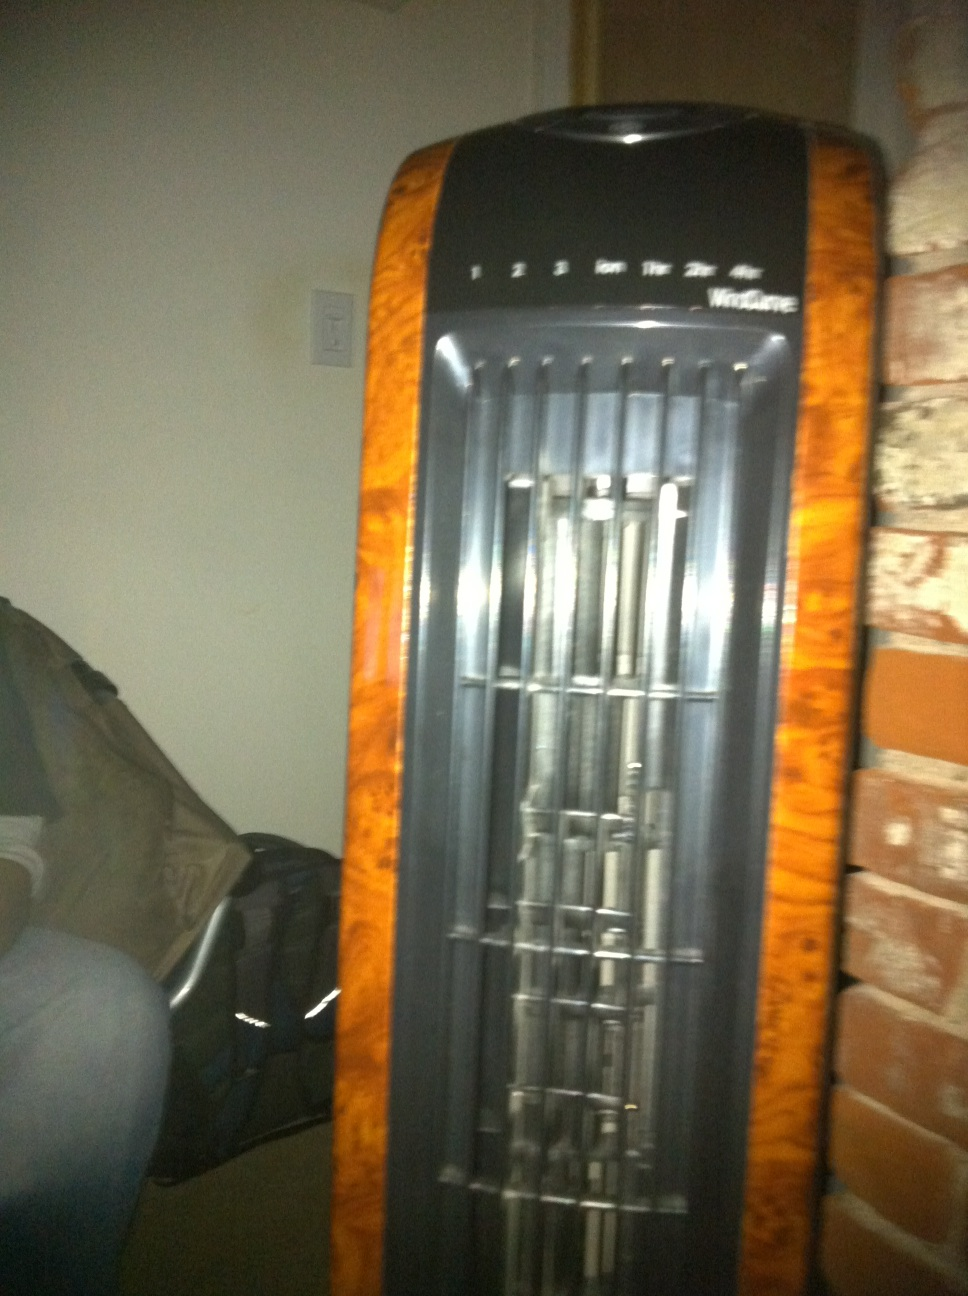Describe what you see. This is an image of an electric tower fan, which seems to have a modern design with several speed settings. The fan is positioned near a red-brick wall, and there's a backpack or a suitcase partially visible in the background. 